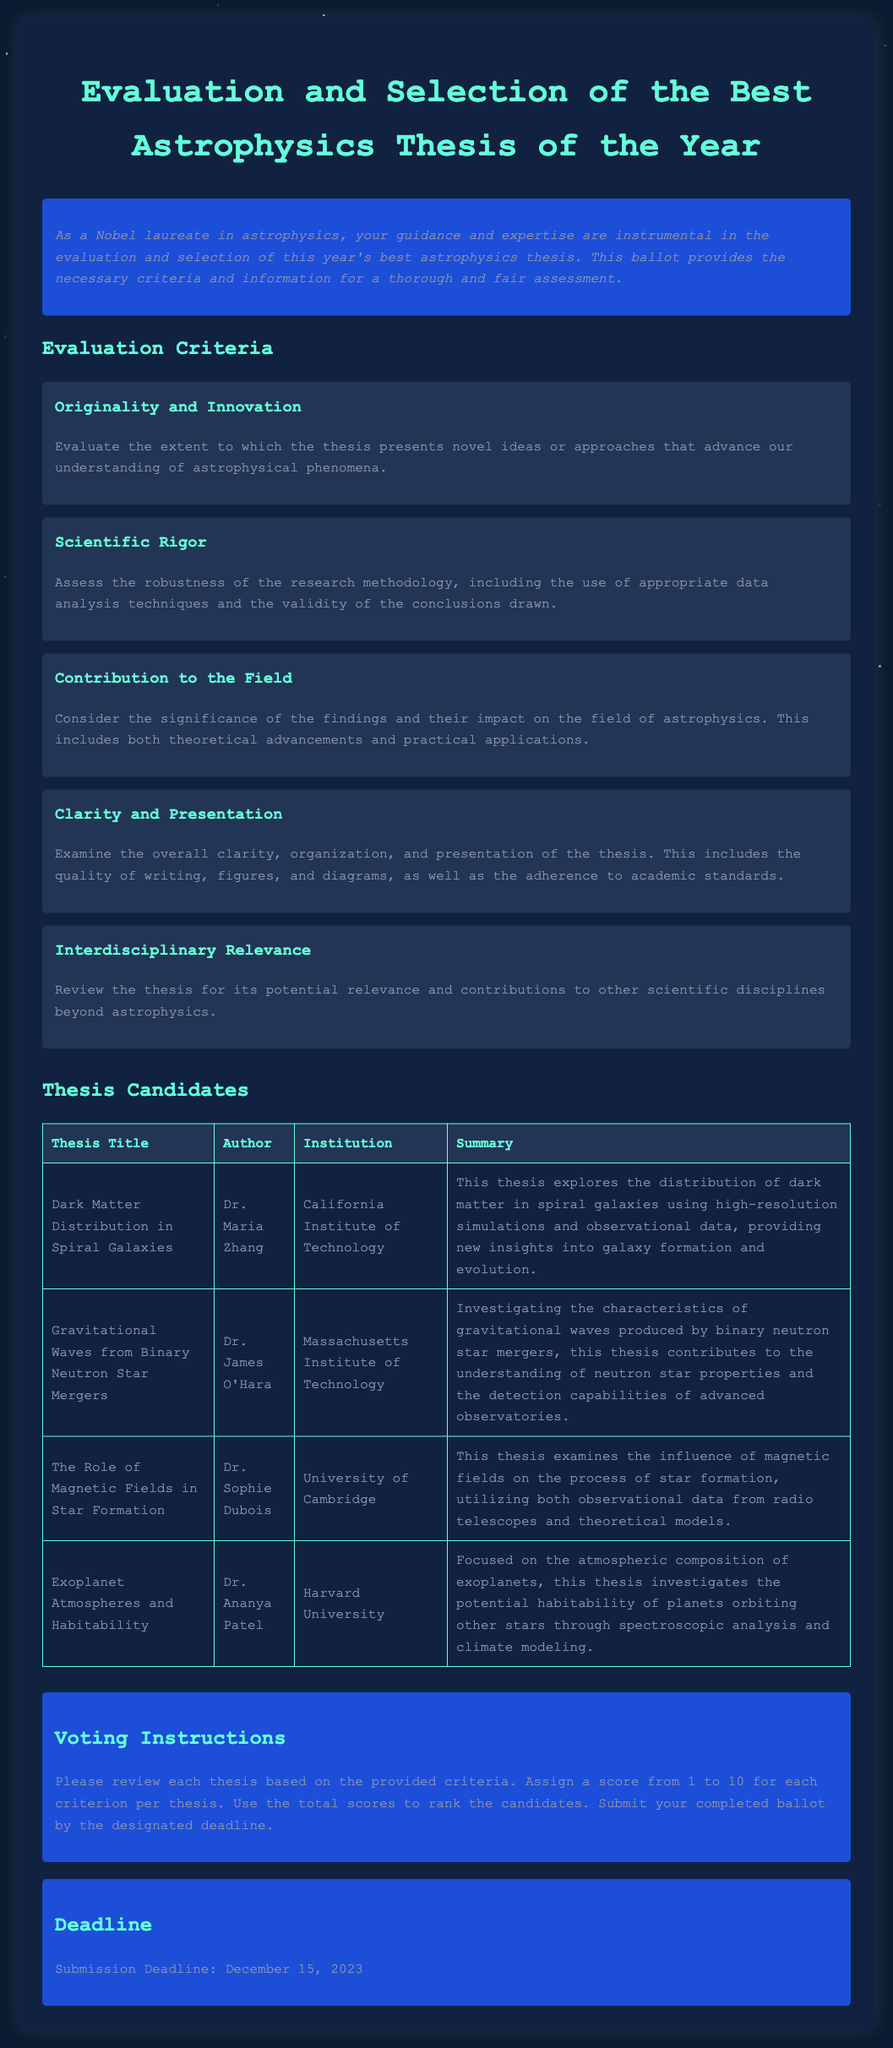What is the submission deadline? The submission deadline is specifically mentioned in the document under the deadline section.
Answer: December 15, 2023 What is one of the evaluation criteria? The document lists multiple evaluation criteria in the criteria section, and one example is provided.
Answer: Originality and Innovation Who is the author of the thesis titled "Exoplanet Atmospheres and Habitability"? The document contains a table where the titles of the theses are matched with their respective authors, providing specific details about authorship.
Answer: Dr. Ananya Patel Which institution did Dr. Maria Zhang represent? The document specifies the institution of each candidate, particularly under the thesis candidates section.
Answer: California Institute of Technology What is the main focus of Dr. Sophie Dubois' thesis? The document provides a summary for each thesis under the candidates section, detailing the main focus of the research.
Answer: The influence of magnetic fields on star formation How many candidates are listed in the document? The document contains a table listing all the thesis candidates, which allows for easy counting of the entries.
Answer: Four What is the overall theme of the document? The document revolves around evaluation and selection, particularly pertaining to astrophysics theses, as stated in the title and overview.
Answer: Evaluation and Selection of the Best Astrophysics Thesis of the Year What should evaluators do to rank the candidates? The instructions section of the document outlines the process that evaluators should follow for scoring the theses.
Answer: Assign a score from 1 to 10 for each criterion per thesis 